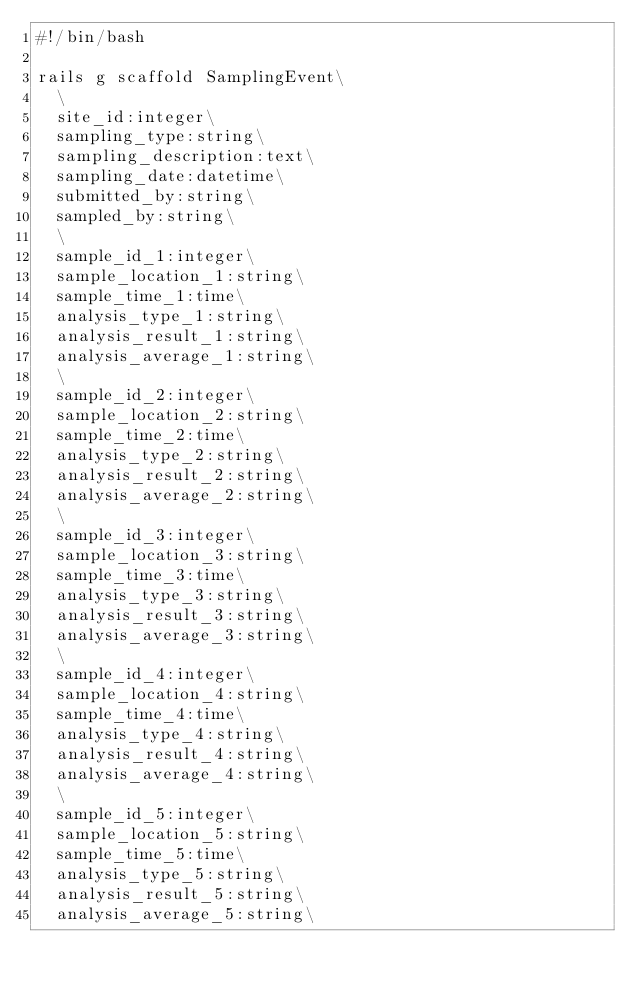Convert code to text. <code><loc_0><loc_0><loc_500><loc_500><_Bash_>#!/bin/bash

rails g scaffold SamplingEvent\
  \
  site_id:integer\
  sampling_type:string\
  sampling_description:text\
  sampling_date:datetime\
  submitted_by:string\
  sampled_by:string\
  \
  sample_id_1:integer\
  sample_location_1:string\
  sample_time_1:time\
  analysis_type_1:string\
  analysis_result_1:string\
  analysis_average_1:string\
  \
  sample_id_2:integer\
  sample_location_2:string\
  sample_time_2:time\
  analysis_type_2:string\
  analysis_result_2:string\
  analysis_average_2:string\
  \
  sample_id_3:integer\
  sample_location_3:string\
  sample_time_3:time\
  analysis_type_3:string\
  analysis_result_3:string\
  analysis_average_3:string\
  \
  sample_id_4:integer\
  sample_location_4:string\
  sample_time_4:time\
  analysis_type_4:string\
  analysis_result_4:string\
  analysis_average_4:string\
  \
  sample_id_5:integer\
  sample_location_5:string\
  sample_time_5:time\
  analysis_type_5:string\
  analysis_result_5:string\
  analysis_average_5:string\
</code> 